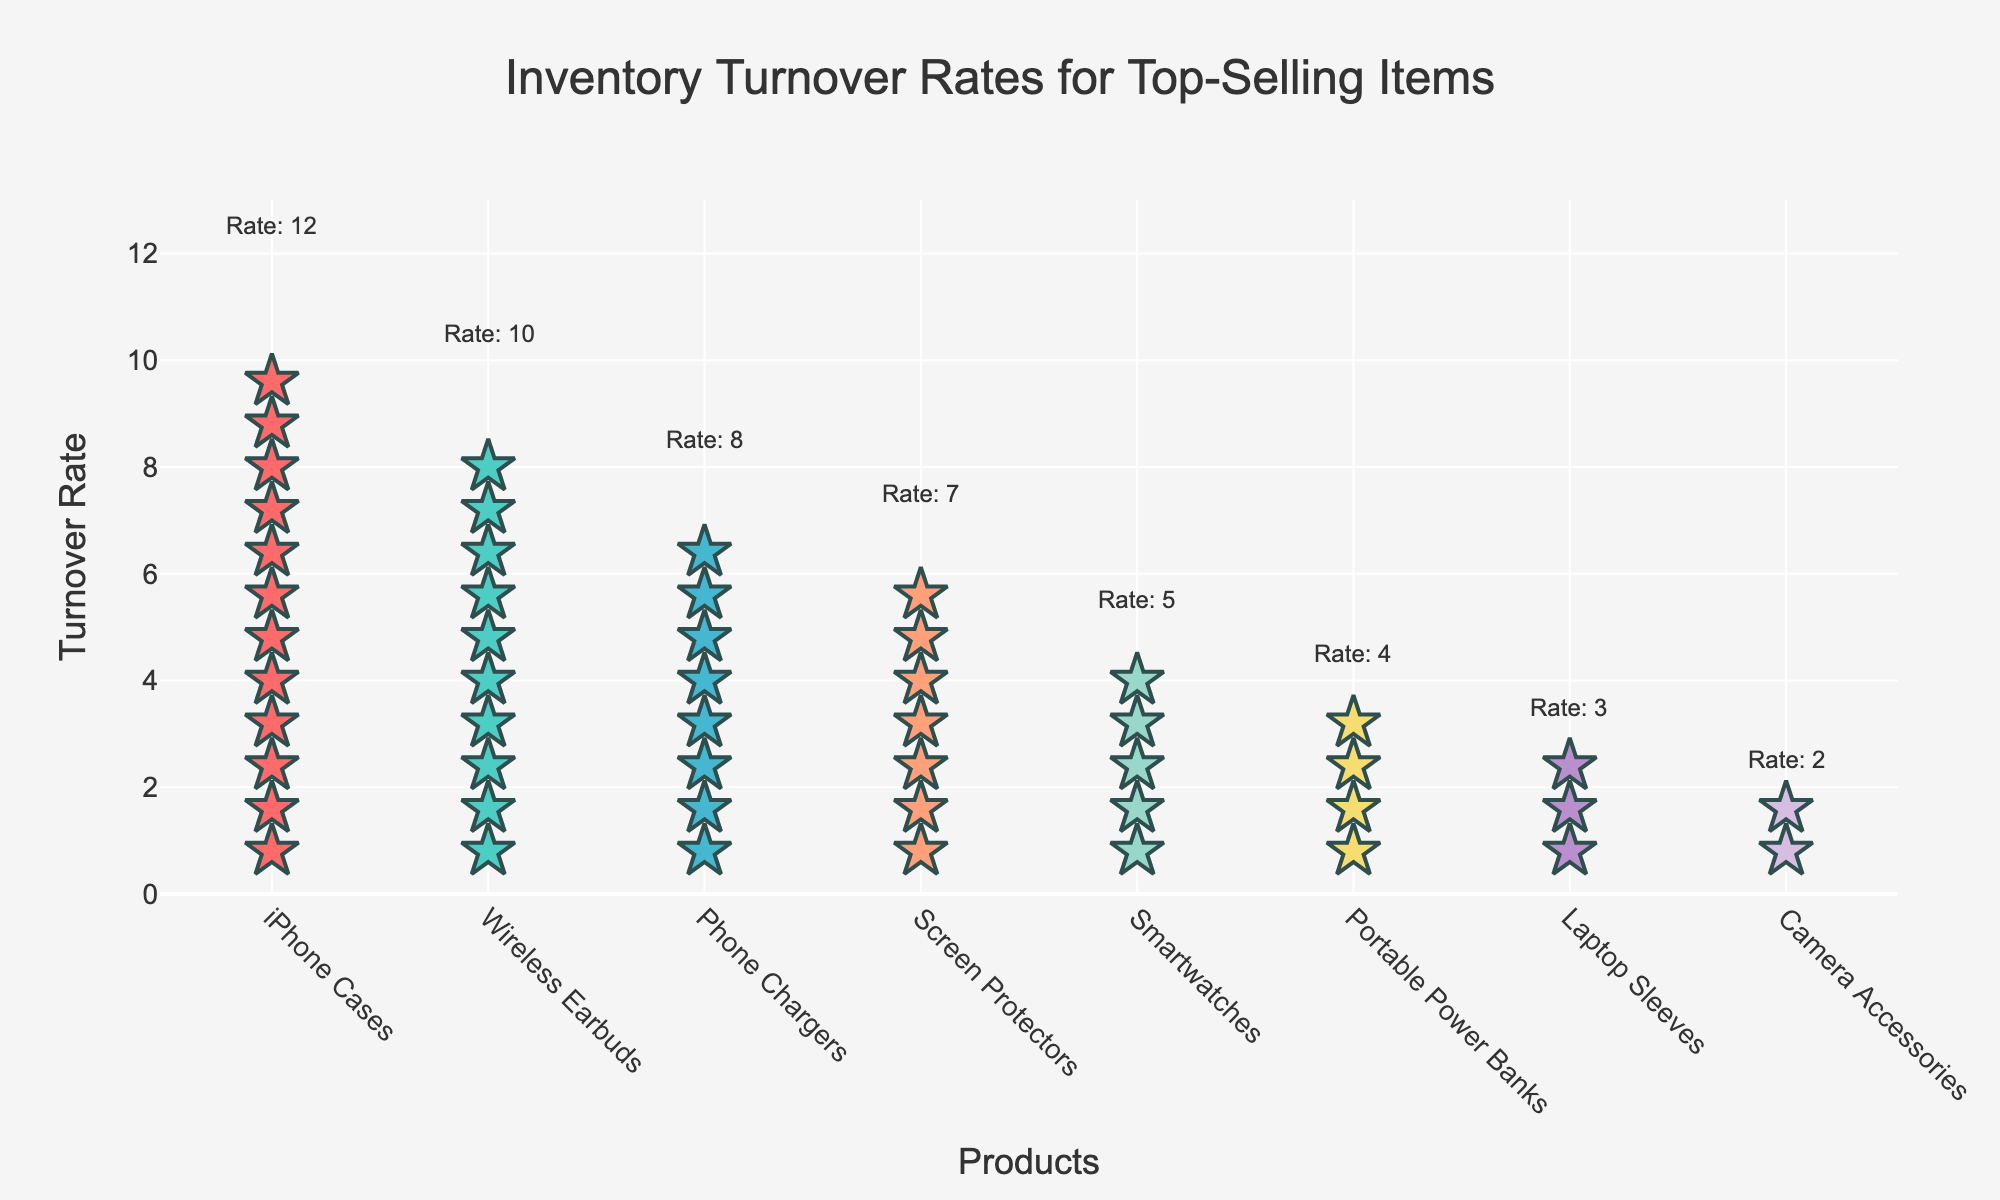what is the turnover rate for Wireless Earbuds? Wireless Earbuds have 10 icons associated with them in the plot. Each icon represents one unit of turnover rate, so the turnover rate is 10
Answer: 10 Which product has the highest turnover rate? The product with the most icons in the plot has the highest turnover rate. iPhone Cases has 12 icons, making it the product with the highest turnover rate
Answer: iPhone Cases What is the difference in turnover rates between Phone Chargers and Smartwatches? Phone Chargers have a turnover rate represented by 8 icons, and Smartwatches have a turnover rate represented by 5 icons. The difference is 8 - 5
Answer: 3 How many products have a turnover rate of 4 or higher? Observing the plot, you can count the number of products with at least 4 icons. The products are iPhone Cases, Wireless Earbuds, Phone Chargers, Screen Protectors, Smartwatches, and Portable Power Banks. There are 6 products in total
Answer: 6 Which product has the lowest turnover rate? The product with the least number of icons in the plot is Camera Accessories, which has 2 icons
Answer: Camera Accessories What is the combined turnover rate for iPhone Cases and Wireless Earbuds? iPhone Cases have a turnover rate of 12, and Wireless Earbuds have a turnover rate of 10. The combined turnover rate is 12 + 10
Answer: 22 Compare the turnover rate of Screen Protectors and Laptop Sleeves. Which is higher? Screen Protectors are represented with 7 icons, while Laptop Sleeves have 3 icons. Screen Protectors have a higher turnover rate
Answer: Screen Protectors Are there more products with a turnover rate below 5 or at least 5? Counting the products, those with a turnover rate below 5 are Portable Power Banks (4), Laptop Sleeves (3), and Camera Accessories (2), totaling 3 products. Those with at least 5 icons are iPhone Cases, Wireless Earbuds, Phone Chargers, Screen Protectors, and Smartwatches, totaling 5 products. There are more products with a turnover rate of at least 5
Answer: at least 5 